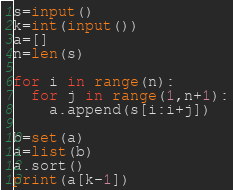Convert code to text. <code><loc_0><loc_0><loc_500><loc_500><_Python_>s=input()
k=int(input())
a=[]
n=len(s)

for i in range(n):
  for j in range(1,n+1):
    a.append(s[i:i+j])

b=set(a)
a=list(b)
a.sort()
print(a[k-1])
</code> 